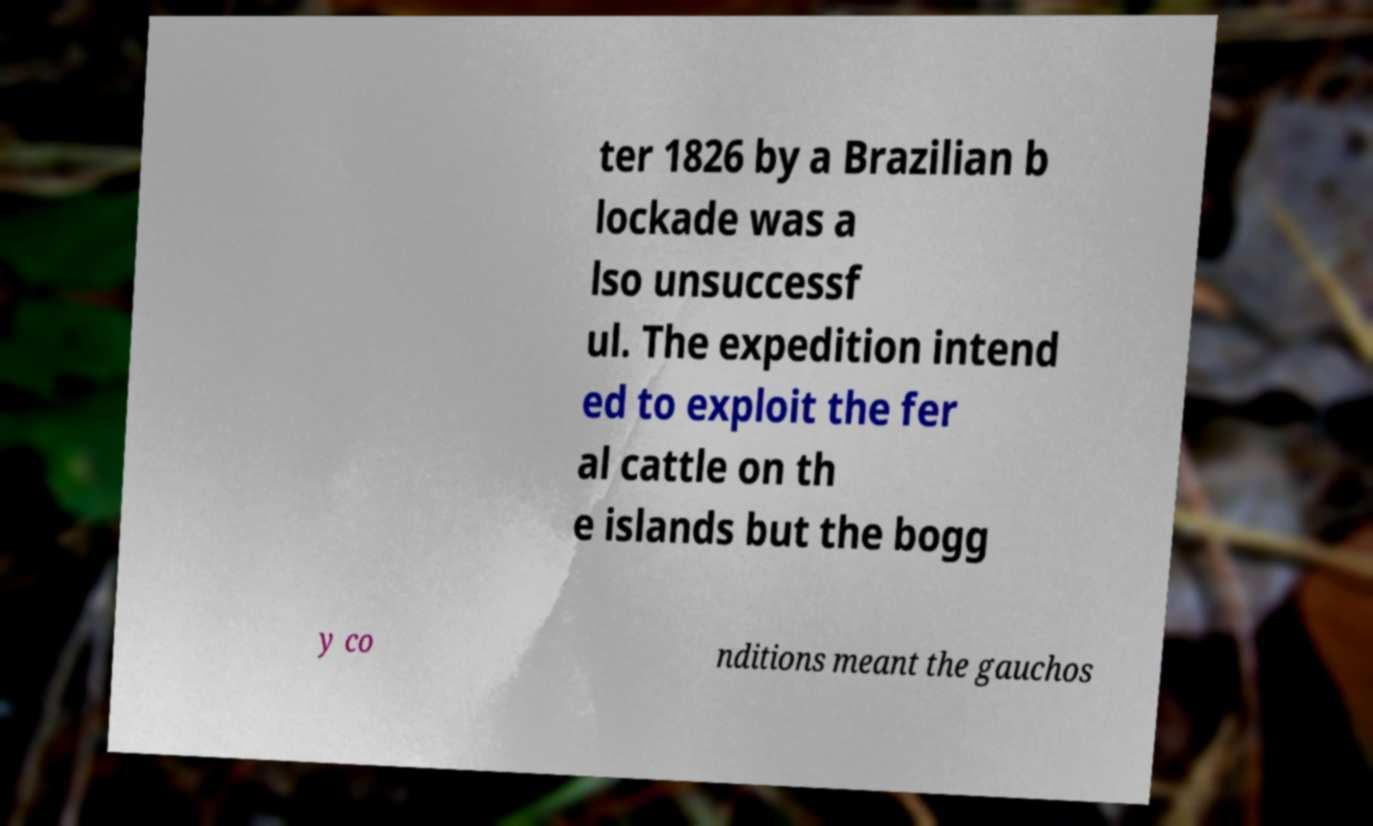What messages or text are displayed in this image? I need them in a readable, typed format. ter 1826 by a Brazilian b lockade was a lso unsuccessf ul. The expedition intend ed to exploit the fer al cattle on th e islands but the bogg y co nditions meant the gauchos 